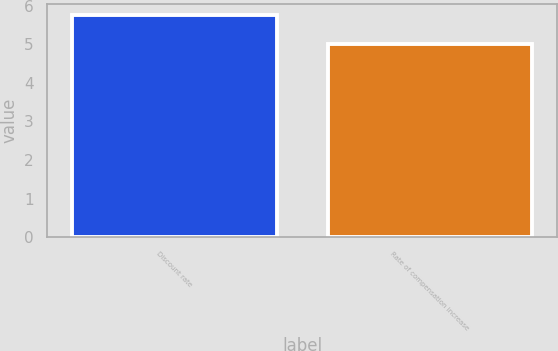<chart> <loc_0><loc_0><loc_500><loc_500><bar_chart><fcel>Discount rate<fcel>Rate of compensation increase<nl><fcel>5.75<fcel>5<nl></chart> 